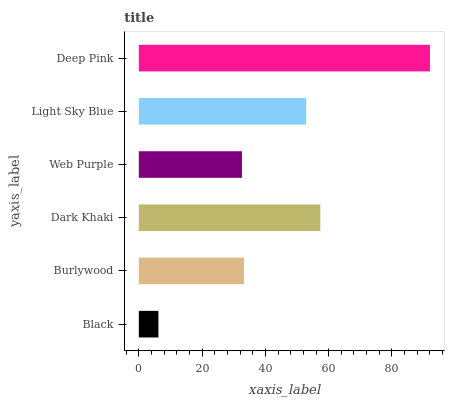Is Black the minimum?
Answer yes or no. Yes. Is Deep Pink the maximum?
Answer yes or no. Yes. Is Burlywood the minimum?
Answer yes or no. No. Is Burlywood the maximum?
Answer yes or no. No. Is Burlywood greater than Black?
Answer yes or no. Yes. Is Black less than Burlywood?
Answer yes or no. Yes. Is Black greater than Burlywood?
Answer yes or no. No. Is Burlywood less than Black?
Answer yes or no. No. Is Light Sky Blue the high median?
Answer yes or no. Yes. Is Burlywood the low median?
Answer yes or no. Yes. Is Burlywood the high median?
Answer yes or no. No. Is Black the low median?
Answer yes or no. No. 